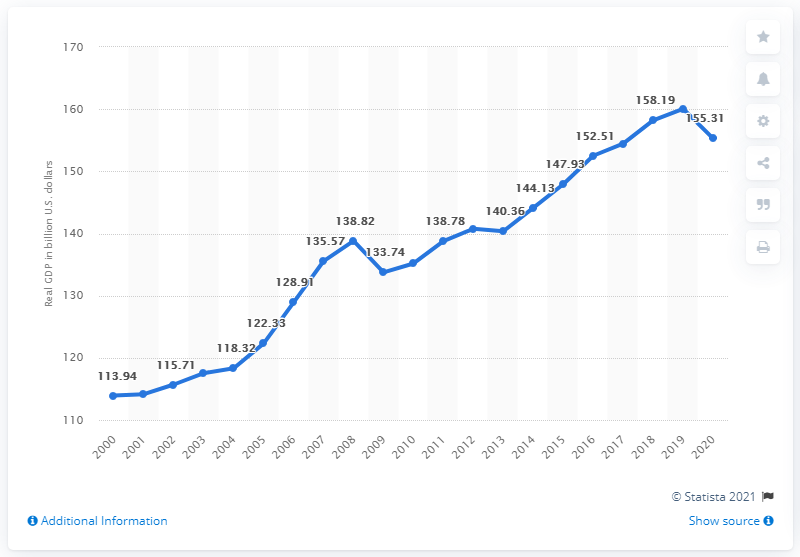Specify some key components in this picture. In the previous year, the Gross Domestic Product (GDP) of Kansas was 160.06 billion dollars. In 2020, the Gross Domestic Product (GDP) of Kansas was 155.31 billion dollars. 